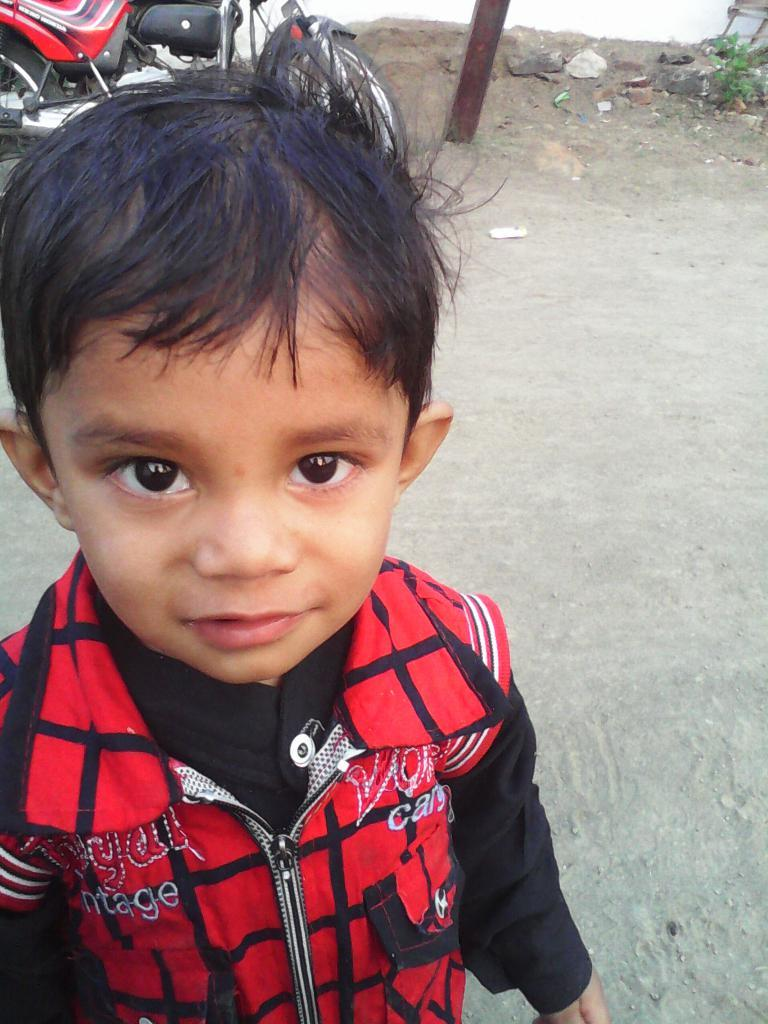What is the main subject of the image? The main subject of the image is a child. Can you describe the child's appearance? The child is wearing clothes and is smiling. What can be seen behind the child? There is a two-wheeler, a pole, sand and stones, and a road visible behind the child. Are there any natural elements in the image? Yes, leaves are present in the image. What type of cracker is the child holding in the image? There is no cracker present in the image; the child is not holding any object. What happens to the whip when the child uses it in the image? There is no whip present in the image, so it cannot be used or observed. 